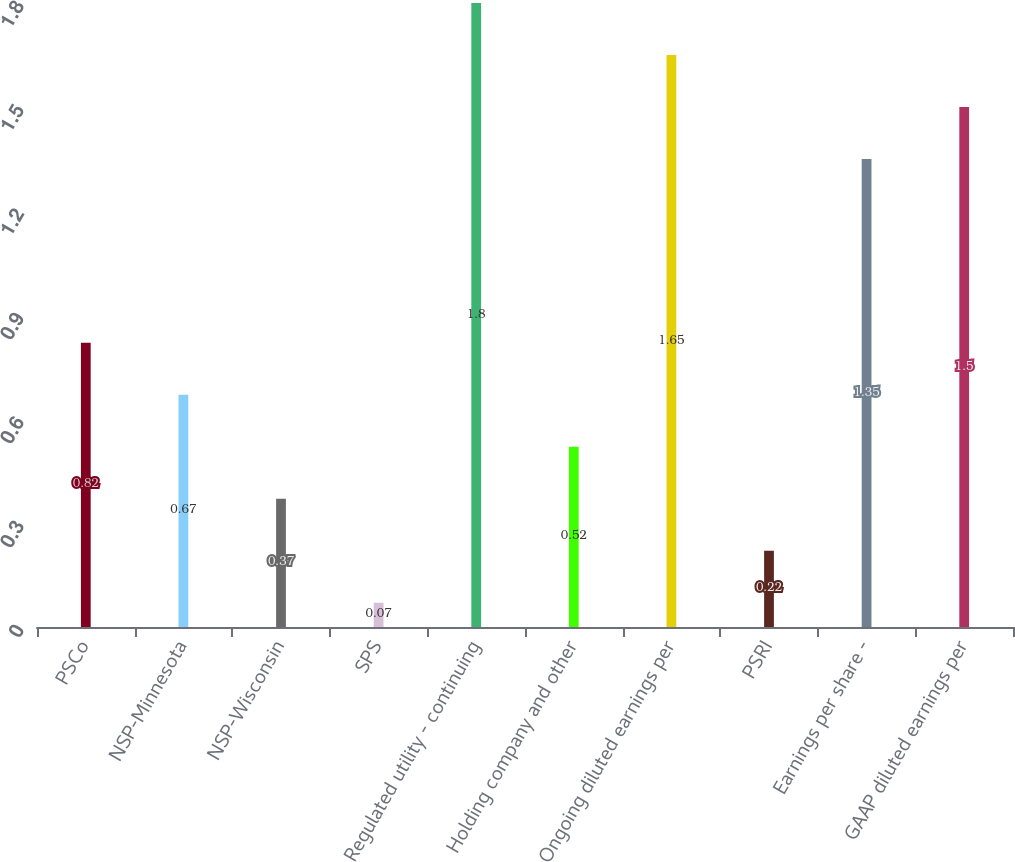Convert chart. <chart><loc_0><loc_0><loc_500><loc_500><bar_chart><fcel>PSCo<fcel>NSP-Minnesota<fcel>NSP-Wisconsin<fcel>SPS<fcel>Regulated utility - continuing<fcel>Holding company and other<fcel>Ongoing diluted earnings per<fcel>PSRI<fcel>Earnings per share -<fcel>GAAP diluted earnings per<nl><fcel>0.82<fcel>0.67<fcel>0.37<fcel>0.07<fcel>1.8<fcel>0.52<fcel>1.65<fcel>0.22<fcel>1.35<fcel>1.5<nl></chart> 